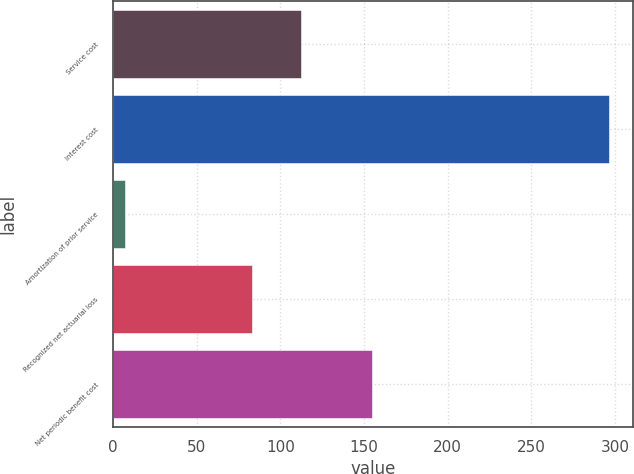Convert chart to OTSL. <chart><loc_0><loc_0><loc_500><loc_500><bar_chart><fcel>Service cost<fcel>Interest cost<fcel>Amortization of prior service<fcel>Recognized net actuarial loss<fcel>Net periodic benefit cost<nl><fcel>112.19<fcel>296.2<fcel>7.3<fcel>83.3<fcel>154.8<nl></chart> 